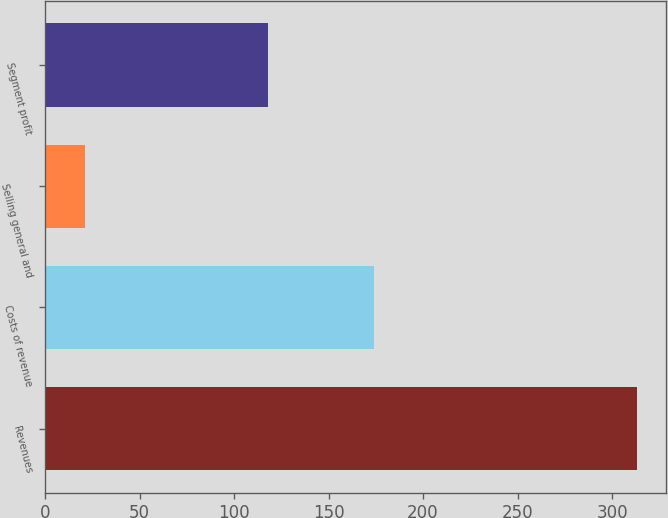Convert chart to OTSL. <chart><loc_0><loc_0><loc_500><loc_500><bar_chart><fcel>Revenues<fcel>Costs of revenue<fcel>Selling general and<fcel>Segment profit<nl><fcel>313<fcel>174<fcel>21<fcel>118<nl></chart> 